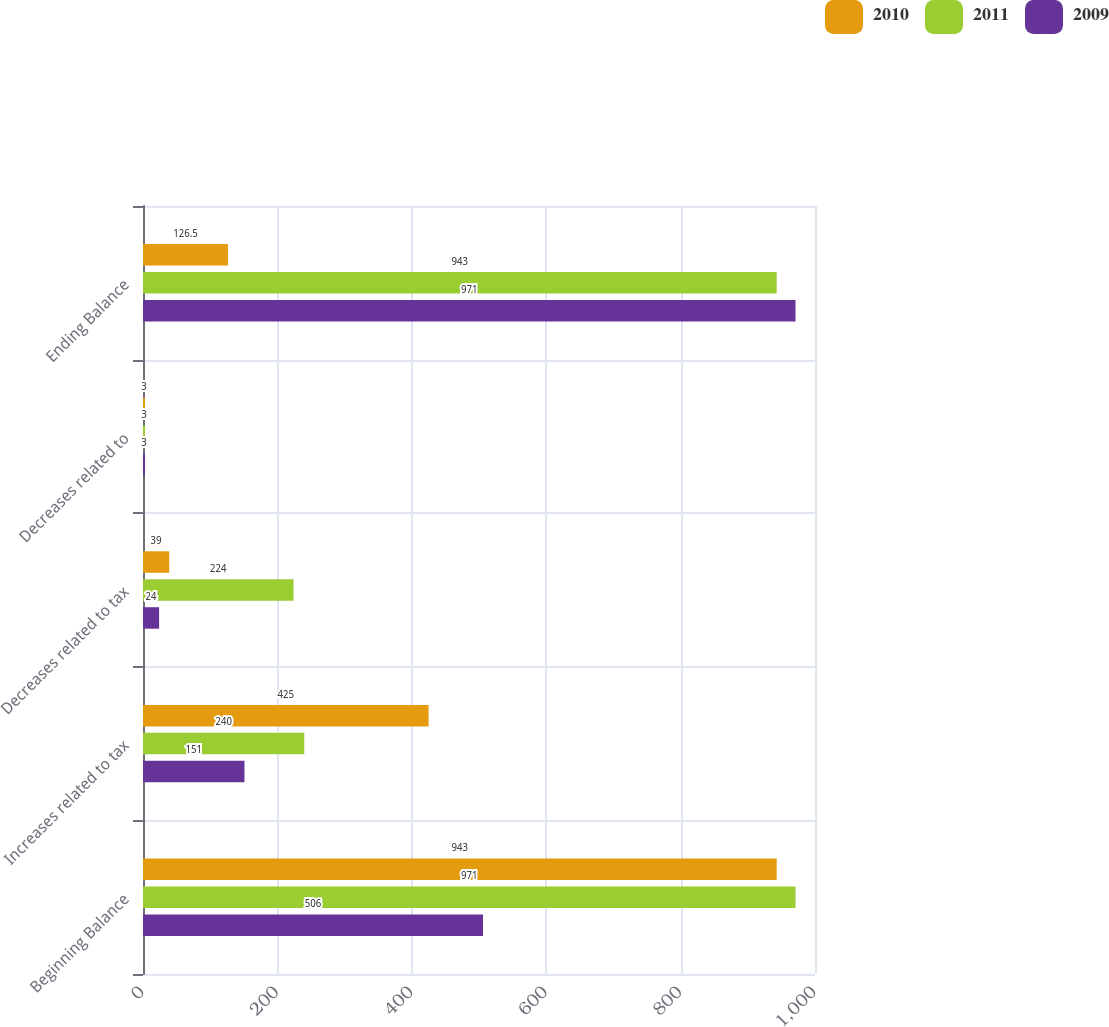Convert chart. <chart><loc_0><loc_0><loc_500><loc_500><stacked_bar_chart><ecel><fcel>Beginning Balance<fcel>Increases related to tax<fcel>Decreases related to tax<fcel>Decreases related to<fcel>Ending Balance<nl><fcel>2010<fcel>943<fcel>425<fcel>39<fcel>3<fcel>126.5<nl><fcel>2011<fcel>971<fcel>240<fcel>224<fcel>3<fcel>943<nl><fcel>2009<fcel>506<fcel>151<fcel>24<fcel>3<fcel>971<nl></chart> 